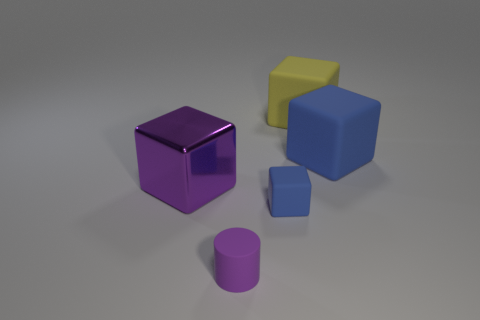Subtract all rubber cubes. How many cubes are left? 1 Subtract all purple blocks. How many blocks are left? 3 Add 5 small blue metal things. How many objects exist? 10 Subtract all cubes. How many objects are left? 1 Subtract all purple spheres. How many purple blocks are left? 1 Subtract all red matte cylinders. Subtract all matte blocks. How many objects are left? 2 Add 2 large blue matte objects. How many large blue matte objects are left? 3 Add 3 purple matte things. How many purple matte things exist? 4 Subtract 0 cyan cubes. How many objects are left? 5 Subtract 3 blocks. How many blocks are left? 1 